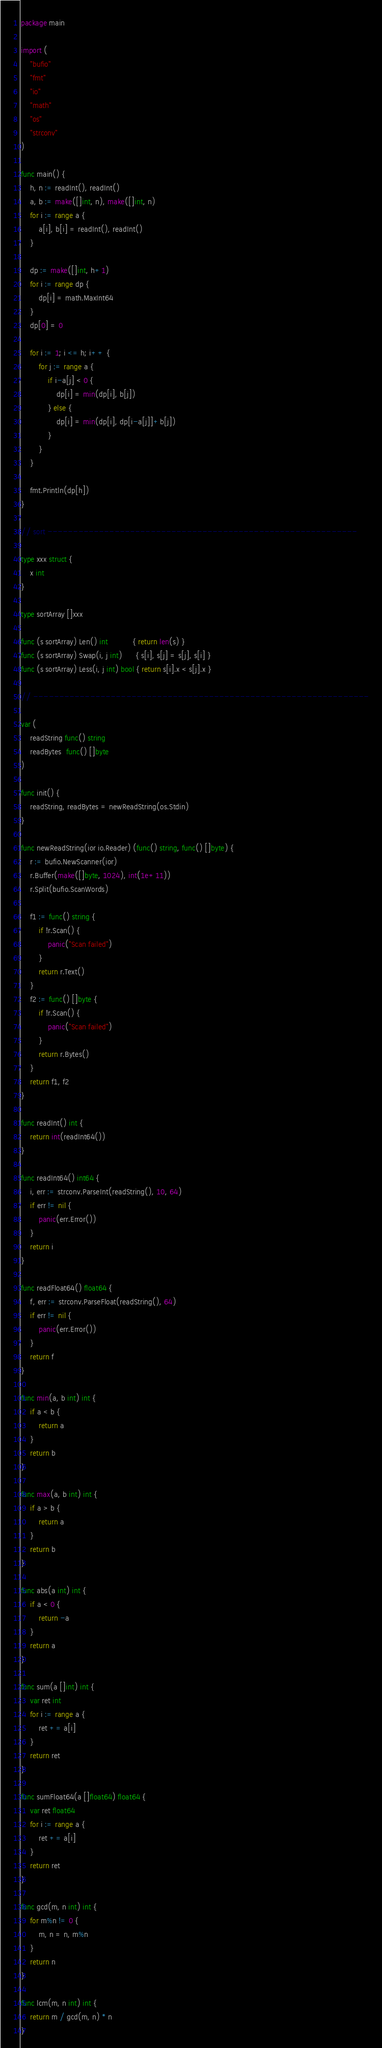Convert code to text. <code><loc_0><loc_0><loc_500><loc_500><_Go_>package main

import (
	"bufio"
	"fmt"
	"io"
	"math"
	"os"
	"strconv"
)

func main() {
	h, n := readInt(), readInt()
	a, b := make([]int, n), make([]int, n)
	for i := range a {
		a[i], b[i] = readInt(), readInt()
	}

	dp := make([]int, h+1)
	for i := range dp {
		dp[i] = math.MaxInt64
	}
	dp[0] = 0

	for i := 1; i <= h; i++ {
		for j := range a {
			if i-a[j] < 0 {
				dp[i] = min(dp[i], b[j])
			} else {
				dp[i] = min(dp[i], dp[i-a[j]]+b[j])
			}
		}
	}

	fmt.Println(dp[h])
}

// sort ------------------------------------------------------------

type xxx struct {
	x int
}

type sortArray []xxx

func (s sortArray) Len() int           { return len(s) }
func (s sortArray) Swap(i, j int)      { s[i], s[j] = s[j], s[i] }
func (s sortArray) Less(i, j int) bool { return s[i].x < s[j].x }

// -----------------------------------------------------------------

var (
	readString func() string
	readBytes  func() []byte
)

func init() {
	readString, readBytes = newReadString(os.Stdin)
}

func newReadString(ior io.Reader) (func() string, func() []byte) {
	r := bufio.NewScanner(ior)
	r.Buffer(make([]byte, 1024), int(1e+11))
	r.Split(bufio.ScanWords)

	f1 := func() string {
		if !r.Scan() {
			panic("Scan failed")
		}
		return r.Text()
	}
	f2 := func() []byte {
		if !r.Scan() {
			panic("Scan failed")
		}
		return r.Bytes()
	}
	return f1, f2
}

func readInt() int {
	return int(readInt64())
}

func readInt64() int64 {
	i, err := strconv.ParseInt(readString(), 10, 64)
	if err != nil {
		panic(err.Error())
	}
	return i
}

func readFloat64() float64 {
	f, err := strconv.ParseFloat(readString(), 64)
	if err != nil {
		panic(err.Error())
	}
	return f
}

func min(a, b int) int {
	if a < b {
		return a
	}
	return b
}

func max(a, b int) int {
	if a > b {
		return a
	}
	return b
}

func abs(a int) int {
	if a < 0 {
		return -a
	}
	return a
}

func sum(a []int) int {
	var ret int
	for i := range a {
		ret += a[i]
	}
	return ret
}

func sumFloat64(a []float64) float64 {
	var ret float64
	for i := range a {
		ret += a[i]
	}
	return ret
}

func gcd(m, n int) int {
	for m%n != 0 {
		m, n = n, m%n
	}
	return n
}

func lcm(m, n int) int {
	return m / gcd(m, n) * n
}
</code> 